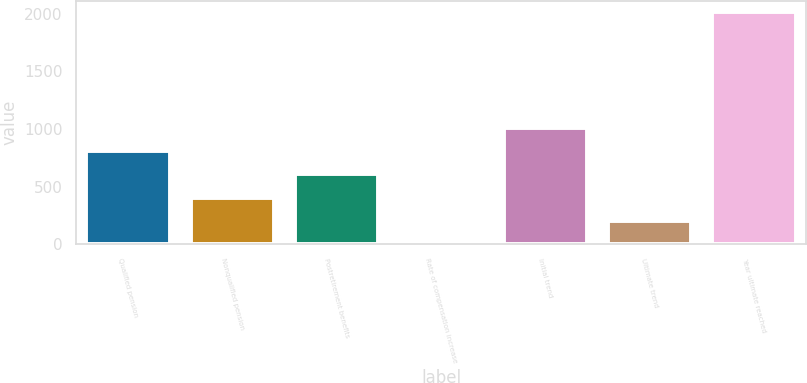Convert chart. <chart><loc_0><loc_0><loc_500><loc_500><bar_chart><fcel>Qualified pension<fcel>Nonqualified pension<fcel>Postretirement benefits<fcel>Rate of compensation increase<fcel>Initial trend<fcel>Ultimate trend<fcel>Year ultimate reached<nl><fcel>808<fcel>406<fcel>607<fcel>4<fcel>1009<fcel>205<fcel>2014<nl></chart> 